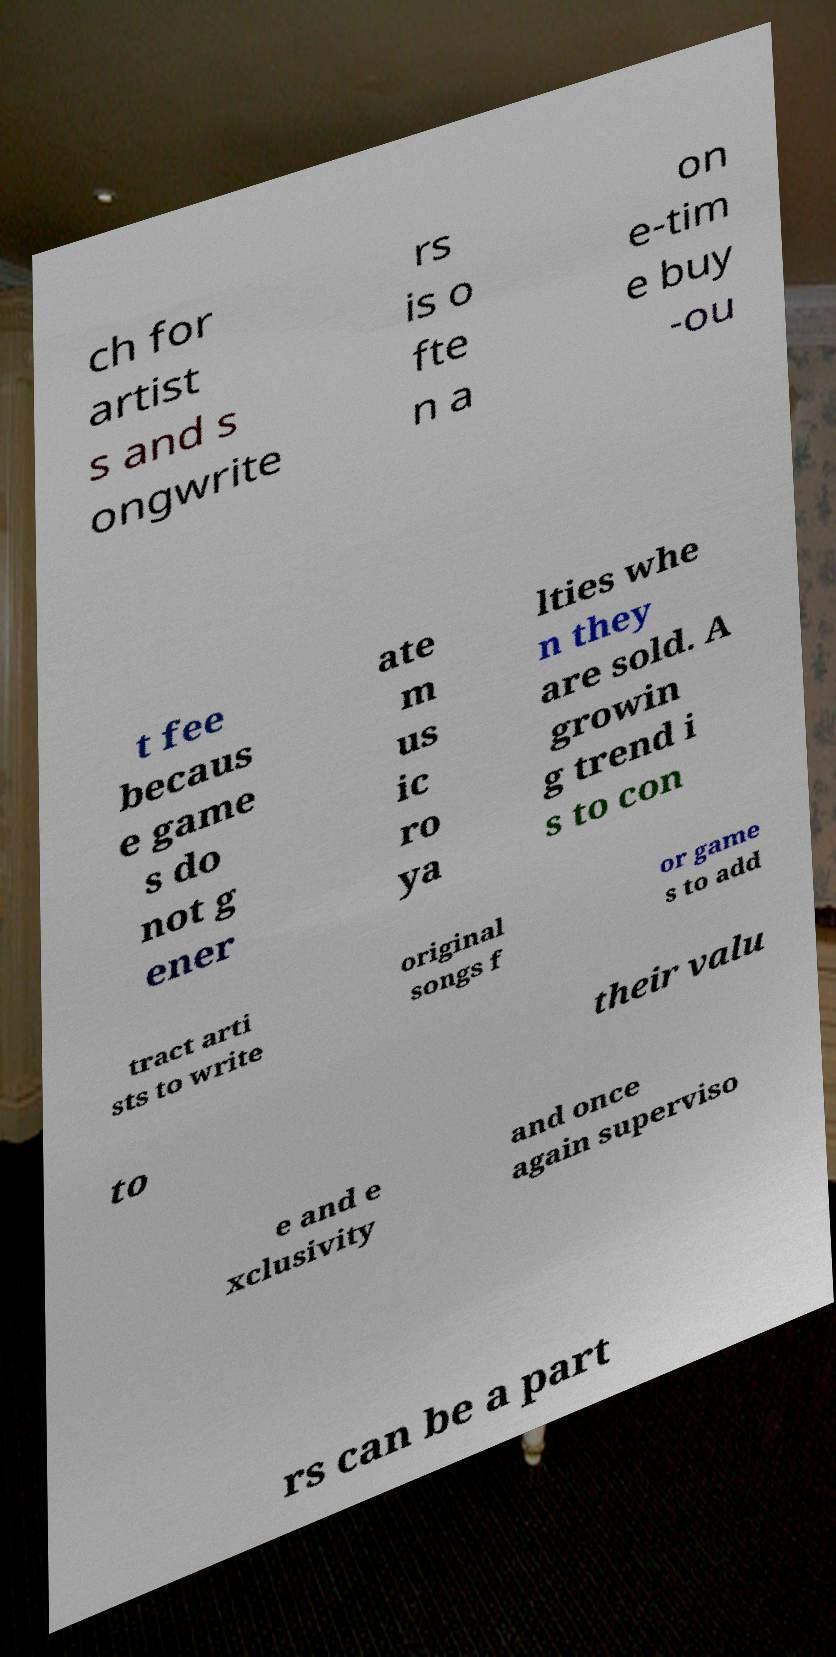For documentation purposes, I need the text within this image transcribed. Could you provide that? ch for artist s and s ongwrite rs is o fte n a on e-tim e buy -ou t fee becaus e game s do not g ener ate m us ic ro ya lties whe n they are sold. A growin g trend i s to con tract arti sts to write original songs f or game s to add to their valu e and e xclusivity and once again superviso rs can be a part 